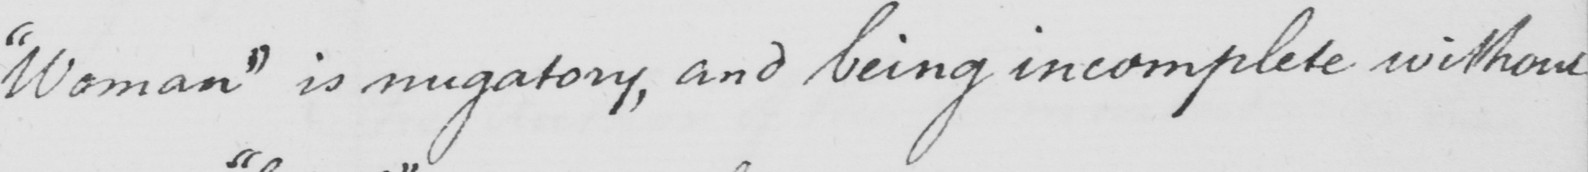Can you read and transcribe this handwriting? " Woman "  is nugatory , and being incomplete without 